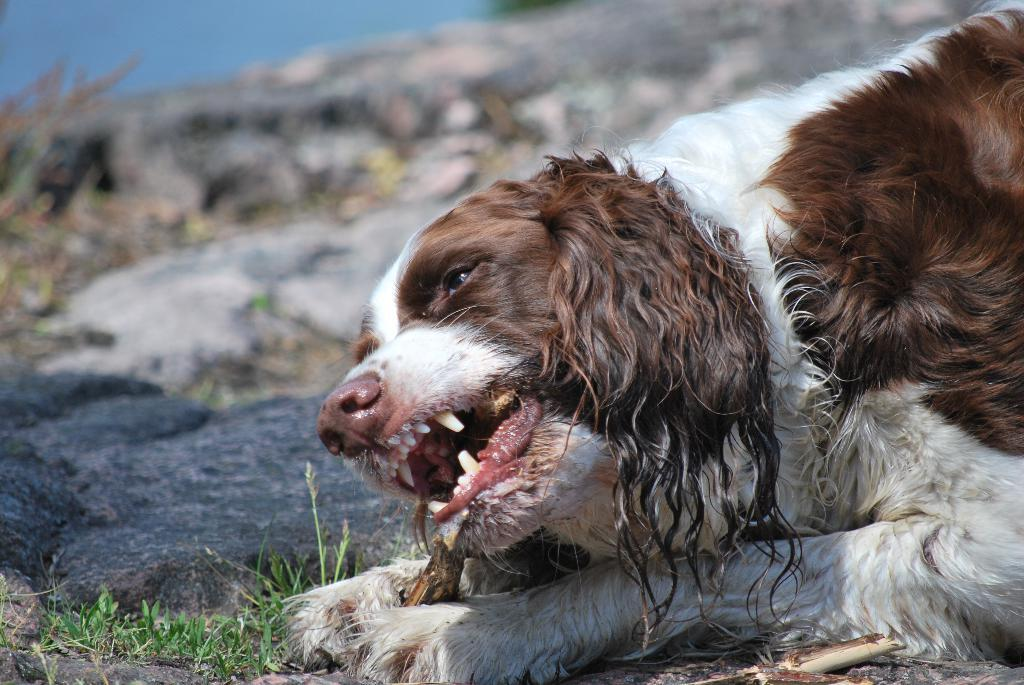What animal can be seen in the image? There is a dog lying on the ground in the image. Where is the dog located in the image? The dog is on the right side of the image. What other object can be seen on the left side of the image? There appears to be a rock on the left side of the image. Can you tell me how many pans are visible in the image? There are no pans present in the image. Is the dog swimming in the image? The dog is lying on the ground, not swimming, in the image. 